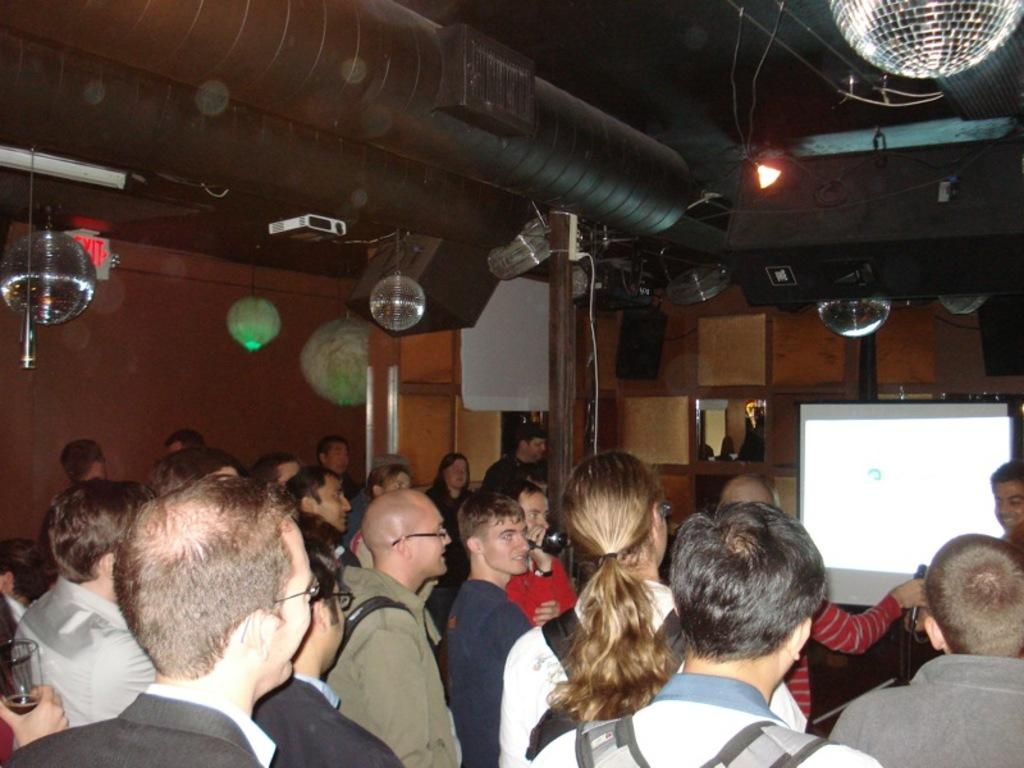What can be seen in the image? There are people standing in the image. What objects are present in the background? There is a projector, decoration lights, an exit board, a pipe, and a projector screen visible in the background. What is the wall like in the background? The wall is visible in the background. What type of insurance is being discussed by the people in the image? There is no indication in the image that the people are discussing insurance, as the focus is on the objects and features in the background. 